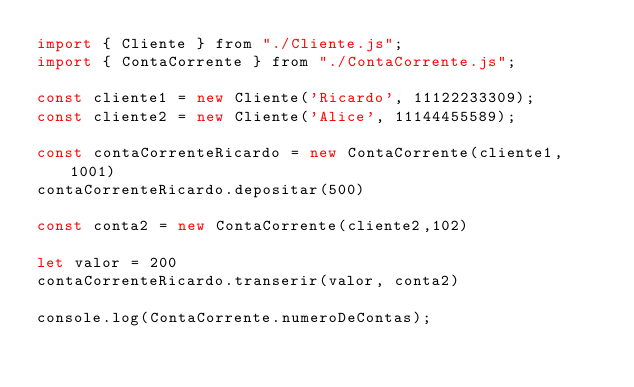Convert code to text. <code><loc_0><loc_0><loc_500><loc_500><_JavaScript_>import { Cliente } from "./Cliente.js";
import { ContaCorrente } from "./ContaCorrente.js";

const cliente1 = new Cliente('Ricardo', 11122233309);
const cliente2 = new Cliente('Alice', 11144455589);

const contaCorrenteRicardo = new ContaCorrente(cliente1, 1001)
contaCorrenteRicardo.depositar(500)

const conta2 = new ContaCorrente(cliente2,102)

let valor = 200
contaCorrenteRicardo.transerir(valor, conta2)

console.log(ContaCorrente.numeroDeContas);
</code> 